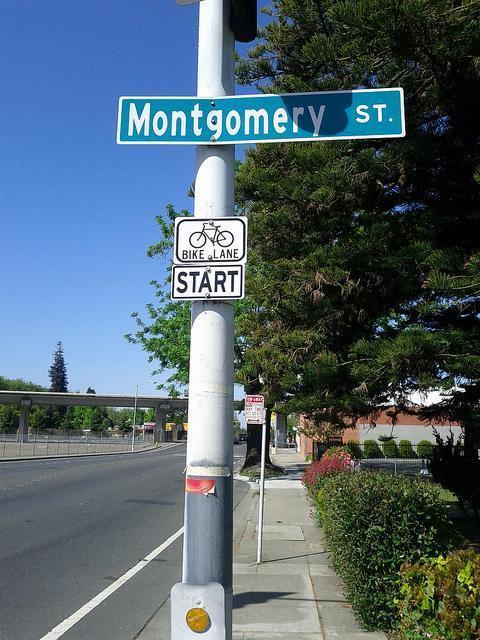How many people in the photo?
Give a very brief answer. 0. 